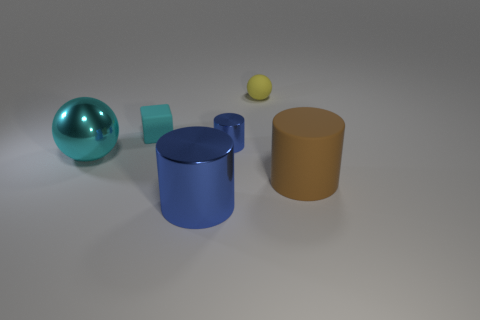The large shiny sphere is what color?
Ensure brevity in your answer.  Cyan. Do the small metallic thing and the large metallic cylinder have the same color?
Your answer should be very brief. Yes. How many small yellow rubber things are on the left side of the blue shiny object in front of the large sphere?
Your answer should be very brief. 0. There is a thing that is in front of the cyan ball and left of the yellow rubber thing; what size is it?
Your response must be concise. Large. What is the material of the blue cylinder right of the big blue thing?
Offer a terse response. Metal. Is there another metal object of the same shape as the yellow object?
Provide a succinct answer. Yes. What number of brown rubber objects have the same shape as the big cyan metallic object?
Make the answer very short. 0. Does the sphere that is on the right side of the small cyan cube have the same size as the object that is to the right of the rubber sphere?
Give a very brief answer. No. The tiny object on the left side of the blue object behind the big cyan metallic thing is what shape?
Provide a short and direct response. Cube. Are there the same number of metallic cylinders that are behind the large blue metallic cylinder and large cyan shiny spheres?
Ensure brevity in your answer.  Yes. 